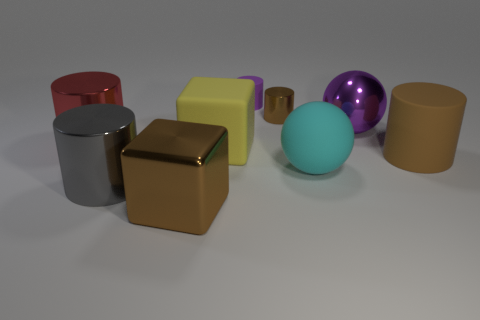What material is the yellow object that is the same size as the brown matte thing?
Make the answer very short. Rubber. Is the number of shiny cylinders that are left of the small purple rubber cylinder less than the number of large yellow matte blocks behind the yellow rubber cube?
Your answer should be very brief. No. What shape is the matte object in front of the big cylinder on the right side of the cyan object?
Give a very brief answer. Sphere. Are any tiny cyan matte cylinders visible?
Give a very brief answer. No. What is the color of the thing to the right of the purple shiny thing?
Provide a short and direct response. Brown. There is a big ball that is the same color as the tiny rubber thing; what is it made of?
Offer a terse response. Metal. Are there any big cubes left of the big matte sphere?
Make the answer very short. Yes. Are there more large metallic cylinders than gray metallic balls?
Offer a terse response. Yes. The ball that is behind the brown cylinder to the right of the metallic cylinder that is behind the red cylinder is what color?
Offer a very short reply. Purple. There is a large cylinder that is made of the same material as the yellow cube; what color is it?
Make the answer very short. Brown. 